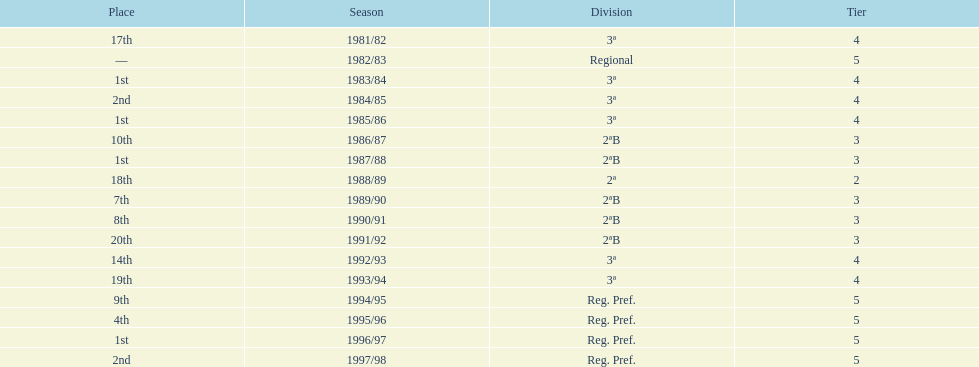What were the number of times second place was earned? 2. 